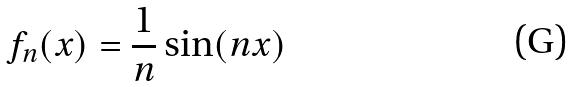Convert formula to latex. <formula><loc_0><loc_0><loc_500><loc_500>f _ { n } ( x ) = \frac { 1 } { n } \sin ( n x )</formula> 